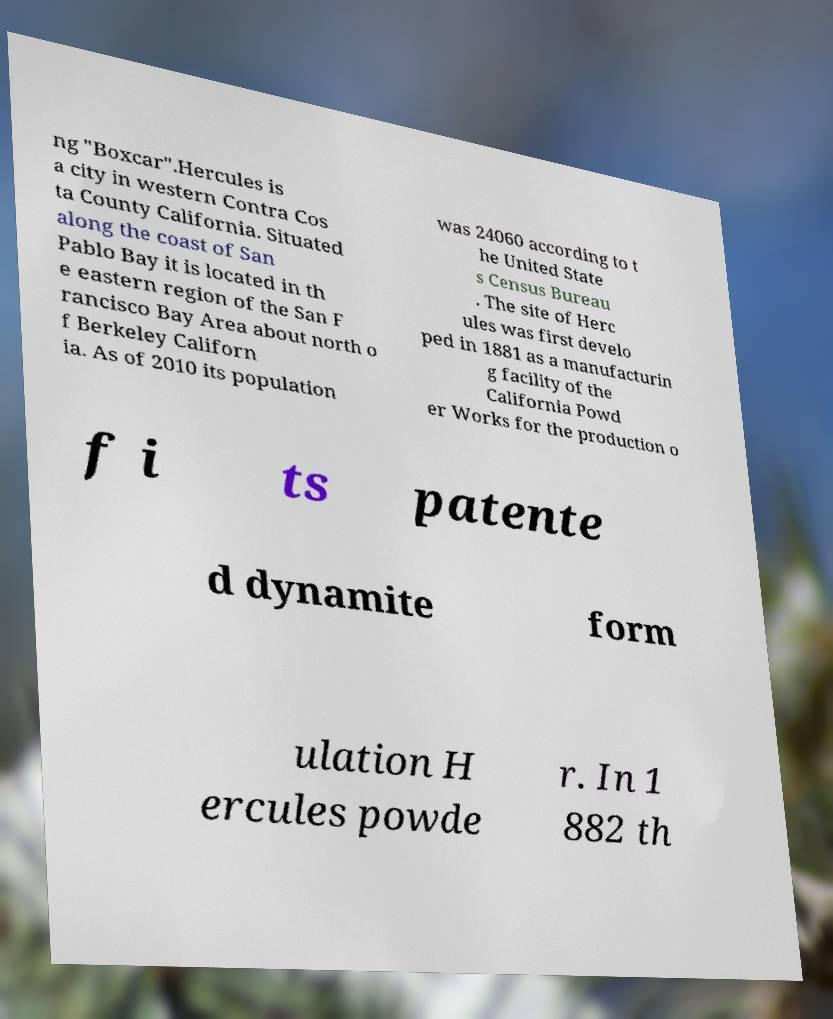Please read and relay the text visible in this image. What does it say? ng "Boxcar".Hercules is a city in western Contra Cos ta County California. Situated along the coast of San Pablo Bay it is located in th e eastern region of the San F rancisco Bay Area about north o f Berkeley Californ ia. As of 2010 its population was 24060 according to t he United State s Census Bureau . The site of Herc ules was first develo ped in 1881 as a manufacturin g facility of the California Powd er Works for the production o f i ts patente d dynamite form ulation H ercules powde r. In 1 882 th 